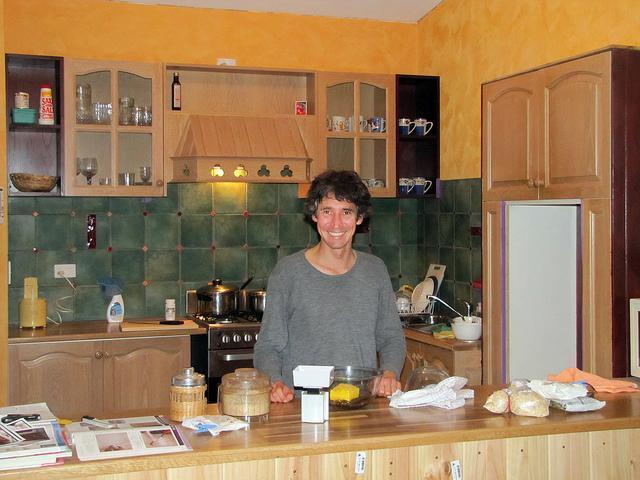How many glasses are on the table?
Give a very brief answer. 0. How many books are there?
Give a very brief answer. 2. 